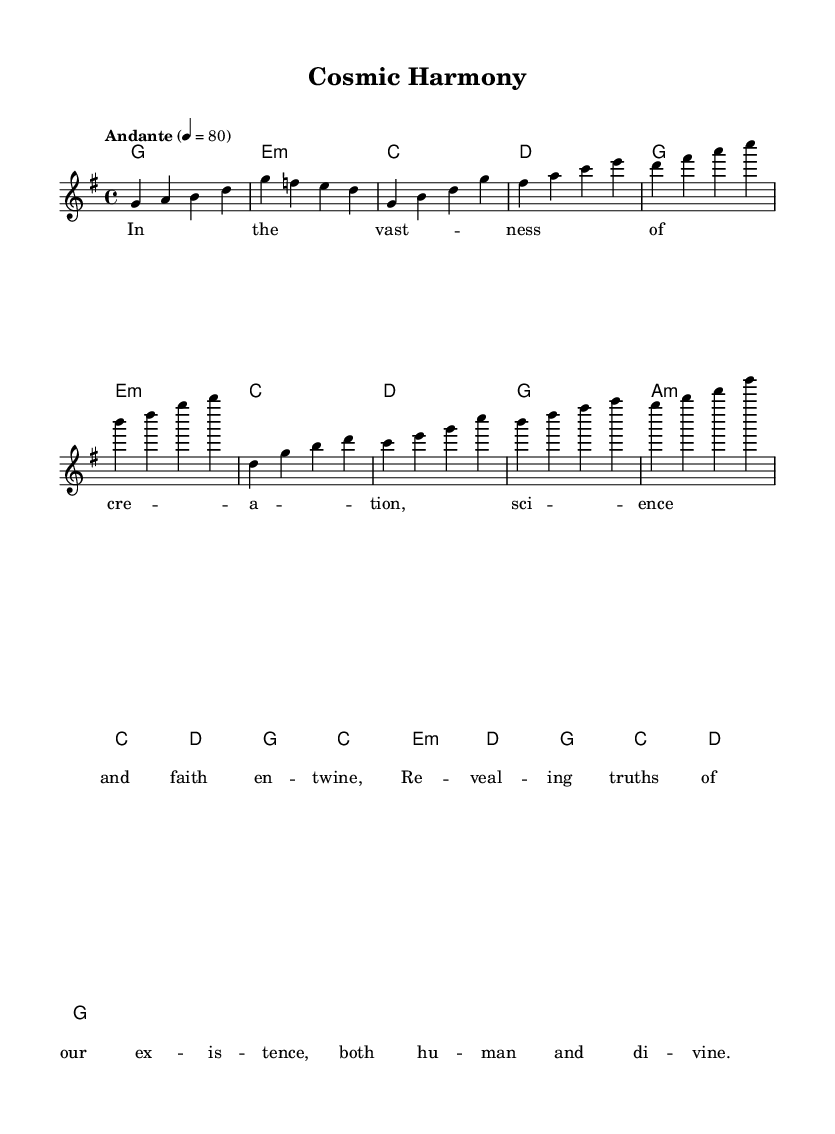What is the key signature of this music? The key signature is G major, which has one sharp (F#). This can be determined from the initial part of the staff where the key signature is notated.
Answer: G major What is the time signature of this music? The time signature is 4/4, which can be identified by the notation at the beginning of the score. This means there are four beats per measure and the quarter note gets one beat.
Answer: 4/4 What is the tempo marking? The tempo marking is "Andante" at a speed of quarter note equals 80. This is indicated at the start of the score.
Answer: Andante 4 = 80 How many measures are in the melody section? There are eight measures in the melody section, which can be counted from the melodyIntro, melodyVerse, and melodyChorus combined.
Answer: 8 What type of harmony is predominantly used in this piece? The harmony used is primarily diatonic chords in the key of G major. This can be seen in the chord changes corresponding to the melody, ensuring they fit within the G major scale.
Answer: Diatonic What is the theme of the lyrics presented in this music? The theme of the lyrics discusses the intertwining of science and faith, reflecting a unity between human understanding and divine existence, which can be gleaned from analyzing the text within the music.
Answer: Science and faith intertwine Which musical form is this piece structured around? This piece is structured around a verse-chorus form, where the melody introduces a theme followed by a repeated chorus that emphasizes the main idea of the lyrics. This can be deduced from the distinct sections labeled in the score.
Answer: Verse-chorus 